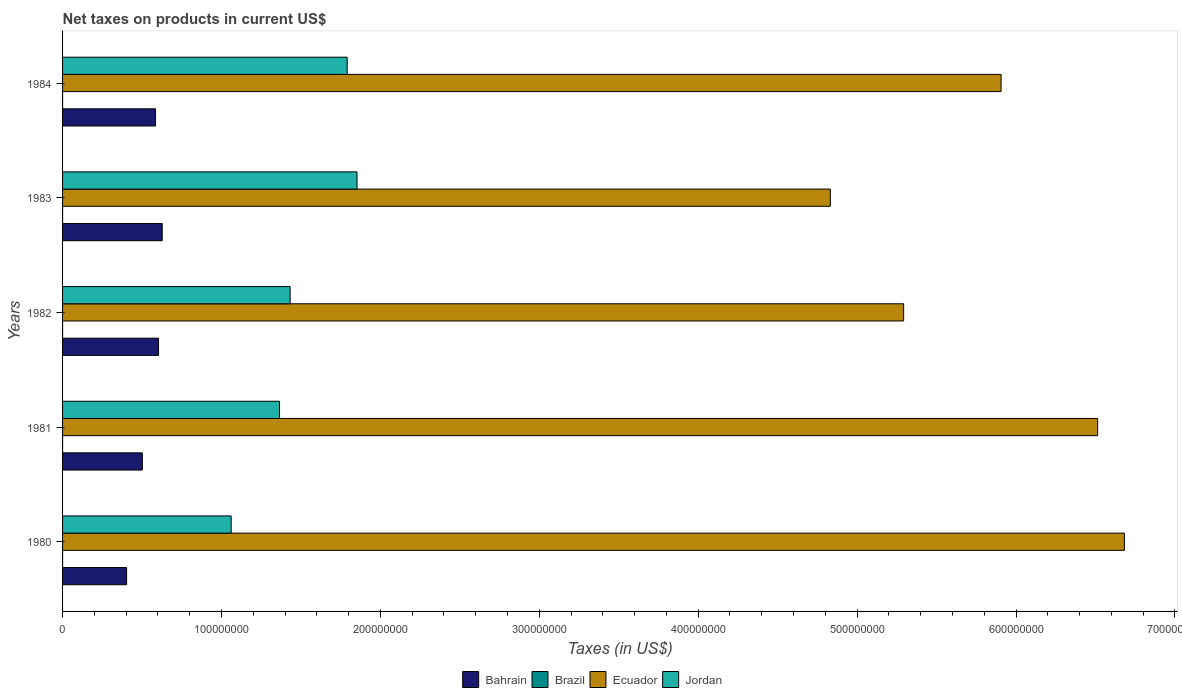How many different coloured bars are there?
Keep it short and to the point. 4. How many bars are there on the 3rd tick from the top?
Offer a very short reply. 4. How many bars are there on the 3rd tick from the bottom?
Ensure brevity in your answer.  4. What is the label of the 2nd group of bars from the top?
Make the answer very short. 1983. In how many cases, is the number of bars for a given year not equal to the number of legend labels?
Offer a very short reply. 0. What is the net taxes on products in Jordan in 1984?
Offer a very short reply. 1.79e+08. Across all years, what is the maximum net taxes on products in Brazil?
Offer a terse response. 12.4. Across all years, what is the minimum net taxes on products in Brazil?
Your answer should be compact. 0.43. What is the total net taxes on products in Ecuador in the graph?
Offer a terse response. 2.92e+09. What is the difference between the net taxes on products in Bahrain in 1981 and that in 1984?
Ensure brevity in your answer.  -8.30e+06. What is the difference between the net taxes on products in Brazil in 1980 and the net taxes on products in Ecuador in 1982?
Your response must be concise. -5.29e+08. What is the average net taxes on products in Bahrain per year?
Ensure brevity in your answer.  5.44e+07. In the year 1983, what is the difference between the net taxes on products in Brazil and net taxes on products in Bahrain?
Provide a succinct answer. -6.27e+07. In how many years, is the net taxes on products in Bahrain greater than 400000000 US$?
Your answer should be compact. 0. What is the ratio of the net taxes on products in Ecuador in 1982 to that in 1983?
Ensure brevity in your answer.  1.1. Is the net taxes on products in Ecuador in 1980 less than that in 1981?
Ensure brevity in your answer.  No. What is the difference between the highest and the second highest net taxes on products in Bahrain?
Make the answer very short. 2.30e+06. What is the difference between the highest and the lowest net taxes on products in Bahrain?
Keep it short and to the point. 2.24e+07. In how many years, is the net taxes on products in Ecuador greater than the average net taxes on products in Ecuador taken over all years?
Your answer should be very brief. 3. Is it the case that in every year, the sum of the net taxes on products in Bahrain and net taxes on products in Brazil is greater than the sum of net taxes on products in Jordan and net taxes on products in Ecuador?
Offer a terse response. No. What does the 3rd bar from the bottom in 1984 represents?
Keep it short and to the point. Ecuador. How many bars are there?
Provide a succinct answer. 20. Are all the bars in the graph horizontal?
Offer a very short reply. Yes. Does the graph contain grids?
Your answer should be very brief. No. What is the title of the graph?
Your answer should be very brief. Net taxes on products in current US$. Does "Middle income" appear as one of the legend labels in the graph?
Keep it short and to the point. No. What is the label or title of the X-axis?
Your answer should be very brief. Taxes (in US$). What is the label or title of the Y-axis?
Keep it short and to the point. Years. What is the Taxes (in US$) in Bahrain in 1980?
Your answer should be very brief. 4.03e+07. What is the Taxes (in US$) in Brazil in 1980?
Give a very brief answer. 0.43. What is the Taxes (in US$) of Ecuador in 1980?
Offer a terse response. 6.68e+08. What is the Taxes (in US$) of Jordan in 1980?
Your answer should be very brief. 1.06e+08. What is the Taxes (in US$) of Bahrain in 1981?
Give a very brief answer. 5.02e+07. What is the Taxes (in US$) of Brazil in 1981?
Offer a terse response. 0.91. What is the Taxes (in US$) of Ecuador in 1981?
Keep it short and to the point. 6.51e+08. What is the Taxes (in US$) in Jordan in 1981?
Provide a succinct answer. 1.36e+08. What is the Taxes (in US$) of Bahrain in 1982?
Offer a terse response. 6.04e+07. What is the Taxes (in US$) in Brazil in 1982?
Your response must be concise. 1.85. What is the Taxes (in US$) in Ecuador in 1982?
Ensure brevity in your answer.  5.29e+08. What is the Taxes (in US$) of Jordan in 1982?
Offer a terse response. 1.43e+08. What is the Taxes (in US$) of Bahrain in 1983?
Your answer should be compact. 6.27e+07. What is the Taxes (in US$) of Brazil in 1983?
Offer a very short reply. 4.33. What is the Taxes (in US$) in Ecuador in 1983?
Make the answer very short. 4.83e+08. What is the Taxes (in US$) of Jordan in 1983?
Your answer should be very brief. 1.85e+08. What is the Taxes (in US$) in Bahrain in 1984?
Give a very brief answer. 5.85e+07. What is the Taxes (in US$) of Brazil in 1984?
Make the answer very short. 12.4. What is the Taxes (in US$) in Ecuador in 1984?
Provide a short and direct response. 5.91e+08. What is the Taxes (in US$) in Jordan in 1984?
Give a very brief answer. 1.79e+08. Across all years, what is the maximum Taxes (in US$) of Bahrain?
Make the answer very short. 6.27e+07. Across all years, what is the maximum Taxes (in US$) of Brazil?
Offer a very short reply. 12.4. Across all years, what is the maximum Taxes (in US$) in Ecuador?
Offer a terse response. 6.68e+08. Across all years, what is the maximum Taxes (in US$) in Jordan?
Your response must be concise. 1.85e+08. Across all years, what is the minimum Taxes (in US$) of Bahrain?
Ensure brevity in your answer.  4.03e+07. Across all years, what is the minimum Taxes (in US$) in Brazil?
Keep it short and to the point. 0.43. Across all years, what is the minimum Taxes (in US$) of Ecuador?
Give a very brief answer. 4.83e+08. Across all years, what is the minimum Taxes (in US$) in Jordan?
Your answer should be compact. 1.06e+08. What is the total Taxes (in US$) of Bahrain in the graph?
Give a very brief answer. 2.72e+08. What is the total Taxes (in US$) in Brazil in the graph?
Provide a short and direct response. 19.94. What is the total Taxes (in US$) in Ecuador in the graph?
Offer a terse response. 2.92e+09. What is the total Taxes (in US$) in Jordan in the graph?
Provide a short and direct response. 7.50e+08. What is the difference between the Taxes (in US$) in Bahrain in 1980 and that in 1981?
Ensure brevity in your answer.  -9.90e+06. What is the difference between the Taxes (in US$) in Brazil in 1980 and that in 1981?
Make the answer very short. -0.48. What is the difference between the Taxes (in US$) in Ecuador in 1980 and that in 1981?
Give a very brief answer. 1.68e+07. What is the difference between the Taxes (in US$) of Jordan in 1980 and that in 1981?
Your answer should be compact. -3.04e+07. What is the difference between the Taxes (in US$) of Bahrain in 1980 and that in 1982?
Provide a short and direct response. -2.01e+07. What is the difference between the Taxes (in US$) in Brazil in 1980 and that in 1982?
Provide a succinct answer. -1.42. What is the difference between the Taxes (in US$) of Ecuador in 1980 and that in 1982?
Keep it short and to the point. 1.39e+08. What is the difference between the Taxes (in US$) of Jordan in 1980 and that in 1982?
Provide a short and direct response. -3.71e+07. What is the difference between the Taxes (in US$) of Bahrain in 1980 and that in 1983?
Make the answer very short. -2.24e+07. What is the difference between the Taxes (in US$) in Brazil in 1980 and that in 1983?
Make the answer very short. -3.9. What is the difference between the Taxes (in US$) in Ecuador in 1980 and that in 1983?
Keep it short and to the point. 1.85e+08. What is the difference between the Taxes (in US$) in Jordan in 1980 and that in 1983?
Your answer should be compact. -7.92e+07. What is the difference between the Taxes (in US$) of Bahrain in 1980 and that in 1984?
Give a very brief answer. -1.82e+07. What is the difference between the Taxes (in US$) of Brazil in 1980 and that in 1984?
Offer a very short reply. -11.97. What is the difference between the Taxes (in US$) of Ecuador in 1980 and that in 1984?
Your answer should be compact. 7.76e+07. What is the difference between the Taxes (in US$) in Jordan in 1980 and that in 1984?
Keep it short and to the point. -7.30e+07. What is the difference between the Taxes (in US$) in Bahrain in 1981 and that in 1982?
Provide a succinct answer. -1.02e+07. What is the difference between the Taxes (in US$) in Brazil in 1981 and that in 1982?
Your answer should be compact. -0.94. What is the difference between the Taxes (in US$) in Ecuador in 1981 and that in 1982?
Provide a succinct answer. 1.22e+08. What is the difference between the Taxes (in US$) in Jordan in 1981 and that in 1982?
Your answer should be compact. -6.70e+06. What is the difference between the Taxes (in US$) in Bahrain in 1981 and that in 1983?
Your answer should be compact. -1.25e+07. What is the difference between the Taxes (in US$) in Brazil in 1981 and that in 1983?
Provide a short and direct response. -3.42. What is the difference between the Taxes (in US$) of Ecuador in 1981 and that in 1983?
Provide a succinct answer. 1.68e+08. What is the difference between the Taxes (in US$) of Jordan in 1981 and that in 1983?
Provide a succinct answer. -4.88e+07. What is the difference between the Taxes (in US$) of Bahrain in 1981 and that in 1984?
Keep it short and to the point. -8.30e+06. What is the difference between the Taxes (in US$) of Brazil in 1981 and that in 1984?
Your answer should be very brief. -11.49. What is the difference between the Taxes (in US$) in Ecuador in 1981 and that in 1984?
Make the answer very short. 6.08e+07. What is the difference between the Taxes (in US$) of Jordan in 1981 and that in 1984?
Offer a very short reply. -4.26e+07. What is the difference between the Taxes (in US$) of Bahrain in 1982 and that in 1983?
Offer a terse response. -2.30e+06. What is the difference between the Taxes (in US$) of Brazil in 1982 and that in 1983?
Provide a succinct answer. -2.48. What is the difference between the Taxes (in US$) in Ecuador in 1982 and that in 1983?
Offer a terse response. 4.61e+07. What is the difference between the Taxes (in US$) in Jordan in 1982 and that in 1983?
Give a very brief answer. -4.21e+07. What is the difference between the Taxes (in US$) of Bahrain in 1982 and that in 1984?
Your response must be concise. 1.90e+06. What is the difference between the Taxes (in US$) in Brazil in 1982 and that in 1984?
Offer a very short reply. -10.55. What is the difference between the Taxes (in US$) of Ecuador in 1982 and that in 1984?
Keep it short and to the point. -6.13e+07. What is the difference between the Taxes (in US$) in Jordan in 1982 and that in 1984?
Provide a succinct answer. -3.59e+07. What is the difference between the Taxes (in US$) of Bahrain in 1983 and that in 1984?
Make the answer very short. 4.20e+06. What is the difference between the Taxes (in US$) of Brazil in 1983 and that in 1984?
Your answer should be compact. -8.07. What is the difference between the Taxes (in US$) of Ecuador in 1983 and that in 1984?
Give a very brief answer. -1.07e+08. What is the difference between the Taxes (in US$) in Jordan in 1983 and that in 1984?
Provide a short and direct response. 6.20e+06. What is the difference between the Taxes (in US$) in Bahrain in 1980 and the Taxes (in US$) in Brazil in 1981?
Ensure brevity in your answer.  4.03e+07. What is the difference between the Taxes (in US$) in Bahrain in 1980 and the Taxes (in US$) in Ecuador in 1981?
Offer a terse response. -6.11e+08. What is the difference between the Taxes (in US$) of Bahrain in 1980 and the Taxes (in US$) of Jordan in 1981?
Keep it short and to the point. -9.62e+07. What is the difference between the Taxes (in US$) of Brazil in 1980 and the Taxes (in US$) of Ecuador in 1981?
Provide a succinct answer. -6.51e+08. What is the difference between the Taxes (in US$) of Brazil in 1980 and the Taxes (in US$) of Jordan in 1981?
Your answer should be compact. -1.36e+08. What is the difference between the Taxes (in US$) of Ecuador in 1980 and the Taxes (in US$) of Jordan in 1981?
Provide a succinct answer. 5.32e+08. What is the difference between the Taxes (in US$) in Bahrain in 1980 and the Taxes (in US$) in Brazil in 1982?
Offer a terse response. 4.03e+07. What is the difference between the Taxes (in US$) in Bahrain in 1980 and the Taxes (in US$) in Ecuador in 1982?
Provide a short and direct response. -4.89e+08. What is the difference between the Taxes (in US$) of Bahrain in 1980 and the Taxes (in US$) of Jordan in 1982?
Your answer should be very brief. -1.03e+08. What is the difference between the Taxes (in US$) in Brazil in 1980 and the Taxes (in US$) in Ecuador in 1982?
Make the answer very short. -5.29e+08. What is the difference between the Taxes (in US$) in Brazil in 1980 and the Taxes (in US$) in Jordan in 1982?
Keep it short and to the point. -1.43e+08. What is the difference between the Taxes (in US$) of Ecuador in 1980 and the Taxes (in US$) of Jordan in 1982?
Your answer should be compact. 5.25e+08. What is the difference between the Taxes (in US$) of Bahrain in 1980 and the Taxes (in US$) of Brazil in 1983?
Offer a very short reply. 4.03e+07. What is the difference between the Taxes (in US$) in Bahrain in 1980 and the Taxes (in US$) in Ecuador in 1983?
Ensure brevity in your answer.  -4.43e+08. What is the difference between the Taxes (in US$) of Bahrain in 1980 and the Taxes (in US$) of Jordan in 1983?
Your response must be concise. -1.45e+08. What is the difference between the Taxes (in US$) in Brazil in 1980 and the Taxes (in US$) in Ecuador in 1983?
Ensure brevity in your answer.  -4.83e+08. What is the difference between the Taxes (in US$) of Brazil in 1980 and the Taxes (in US$) of Jordan in 1983?
Offer a very short reply. -1.85e+08. What is the difference between the Taxes (in US$) of Ecuador in 1980 and the Taxes (in US$) of Jordan in 1983?
Your answer should be very brief. 4.83e+08. What is the difference between the Taxes (in US$) of Bahrain in 1980 and the Taxes (in US$) of Brazil in 1984?
Ensure brevity in your answer.  4.03e+07. What is the difference between the Taxes (in US$) of Bahrain in 1980 and the Taxes (in US$) of Ecuador in 1984?
Give a very brief answer. -5.50e+08. What is the difference between the Taxes (in US$) of Bahrain in 1980 and the Taxes (in US$) of Jordan in 1984?
Your response must be concise. -1.39e+08. What is the difference between the Taxes (in US$) in Brazil in 1980 and the Taxes (in US$) in Ecuador in 1984?
Offer a very short reply. -5.91e+08. What is the difference between the Taxes (in US$) of Brazil in 1980 and the Taxes (in US$) of Jordan in 1984?
Give a very brief answer. -1.79e+08. What is the difference between the Taxes (in US$) in Ecuador in 1980 and the Taxes (in US$) in Jordan in 1984?
Your answer should be very brief. 4.89e+08. What is the difference between the Taxes (in US$) of Bahrain in 1981 and the Taxes (in US$) of Brazil in 1982?
Keep it short and to the point. 5.02e+07. What is the difference between the Taxes (in US$) of Bahrain in 1981 and the Taxes (in US$) of Ecuador in 1982?
Provide a short and direct response. -4.79e+08. What is the difference between the Taxes (in US$) of Bahrain in 1981 and the Taxes (in US$) of Jordan in 1982?
Provide a short and direct response. -9.30e+07. What is the difference between the Taxes (in US$) of Brazil in 1981 and the Taxes (in US$) of Ecuador in 1982?
Offer a terse response. -5.29e+08. What is the difference between the Taxes (in US$) in Brazil in 1981 and the Taxes (in US$) in Jordan in 1982?
Provide a short and direct response. -1.43e+08. What is the difference between the Taxes (in US$) in Ecuador in 1981 and the Taxes (in US$) in Jordan in 1982?
Make the answer very short. 5.08e+08. What is the difference between the Taxes (in US$) in Bahrain in 1981 and the Taxes (in US$) in Brazil in 1983?
Your answer should be very brief. 5.02e+07. What is the difference between the Taxes (in US$) of Bahrain in 1981 and the Taxes (in US$) of Ecuador in 1983?
Give a very brief answer. -4.33e+08. What is the difference between the Taxes (in US$) in Bahrain in 1981 and the Taxes (in US$) in Jordan in 1983?
Offer a very short reply. -1.35e+08. What is the difference between the Taxes (in US$) in Brazil in 1981 and the Taxes (in US$) in Ecuador in 1983?
Make the answer very short. -4.83e+08. What is the difference between the Taxes (in US$) of Brazil in 1981 and the Taxes (in US$) of Jordan in 1983?
Give a very brief answer. -1.85e+08. What is the difference between the Taxes (in US$) in Ecuador in 1981 and the Taxes (in US$) in Jordan in 1983?
Make the answer very short. 4.66e+08. What is the difference between the Taxes (in US$) of Bahrain in 1981 and the Taxes (in US$) of Brazil in 1984?
Ensure brevity in your answer.  5.02e+07. What is the difference between the Taxes (in US$) of Bahrain in 1981 and the Taxes (in US$) of Ecuador in 1984?
Your response must be concise. -5.40e+08. What is the difference between the Taxes (in US$) of Bahrain in 1981 and the Taxes (in US$) of Jordan in 1984?
Ensure brevity in your answer.  -1.29e+08. What is the difference between the Taxes (in US$) in Brazil in 1981 and the Taxes (in US$) in Ecuador in 1984?
Offer a very short reply. -5.91e+08. What is the difference between the Taxes (in US$) of Brazil in 1981 and the Taxes (in US$) of Jordan in 1984?
Offer a terse response. -1.79e+08. What is the difference between the Taxes (in US$) of Ecuador in 1981 and the Taxes (in US$) of Jordan in 1984?
Your response must be concise. 4.72e+08. What is the difference between the Taxes (in US$) of Bahrain in 1982 and the Taxes (in US$) of Brazil in 1983?
Provide a succinct answer. 6.04e+07. What is the difference between the Taxes (in US$) of Bahrain in 1982 and the Taxes (in US$) of Ecuador in 1983?
Your answer should be very brief. -4.23e+08. What is the difference between the Taxes (in US$) of Bahrain in 1982 and the Taxes (in US$) of Jordan in 1983?
Keep it short and to the point. -1.25e+08. What is the difference between the Taxes (in US$) in Brazil in 1982 and the Taxes (in US$) in Ecuador in 1983?
Provide a short and direct response. -4.83e+08. What is the difference between the Taxes (in US$) in Brazil in 1982 and the Taxes (in US$) in Jordan in 1983?
Your answer should be very brief. -1.85e+08. What is the difference between the Taxes (in US$) of Ecuador in 1982 and the Taxes (in US$) of Jordan in 1983?
Offer a very short reply. 3.44e+08. What is the difference between the Taxes (in US$) of Bahrain in 1982 and the Taxes (in US$) of Brazil in 1984?
Give a very brief answer. 6.04e+07. What is the difference between the Taxes (in US$) in Bahrain in 1982 and the Taxes (in US$) in Ecuador in 1984?
Offer a terse response. -5.30e+08. What is the difference between the Taxes (in US$) of Bahrain in 1982 and the Taxes (in US$) of Jordan in 1984?
Your answer should be very brief. -1.19e+08. What is the difference between the Taxes (in US$) in Brazil in 1982 and the Taxes (in US$) in Ecuador in 1984?
Ensure brevity in your answer.  -5.91e+08. What is the difference between the Taxes (in US$) in Brazil in 1982 and the Taxes (in US$) in Jordan in 1984?
Provide a succinct answer. -1.79e+08. What is the difference between the Taxes (in US$) of Ecuador in 1982 and the Taxes (in US$) of Jordan in 1984?
Give a very brief answer. 3.50e+08. What is the difference between the Taxes (in US$) of Bahrain in 1983 and the Taxes (in US$) of Brazil in 1984?
Offer a terse response. 6.27e+07. What is the difference between the Taxes (in US$) of Bahrain in 1983 and the Taxes (in US$) of Ecuador in 1984?
Keep it short and to the point. -5.28e+08. What is the difference between the Taxes (in US$) in Bahrain in 1983 and the Taxes (in US$) in Jordan in 1984?
Keep it short and to the point. -1.16e+08. What is the difference between the Taxes (in US$) of Brazil in 1983 and the Taxes (in US$) of Ecuador in 1984?
Your answer should be very brief. -5.91e+08. What is the difference between the Taxes (in US$) of Brazil in 1983 and the Taxes (in US$) of Jordan in 1984?
Ensure brevity in your answer.  -1.79e+08. What is the difference between the Taxes (in US$) of Ecuador in 1983 and the Taxes (in US$) of Jordan in 1984?
Ensure brevity in your answer.  3.04e+08. What is the average Taxes (in US$) in Bahrain per year?
Provide a succinct answer. 5.44e+07. What is the average Taxes (in US$) in Brazil per year?
Provide a succinct answer. 3.99. What is the average Taxes (in US$) in Ecuador per year?
Offer a terse response. 5.85e+08. What is the average Taxes (in US$) of Jordan per year?
Provide a short and direct response. 1.50e+08. In the year 1980, what is the difference between the Taxes (in US$) of Bahrain and Taxes (in US$) of Brazil?
Provide a short and direct response. 4.03e+07. In the year 1980, what is the difference between the Taxes (in US$) in Bahrain and Taxes (in US$) in Ecuador?
Ensure brevity in your answer.  -6.28e+08. In the year 1980, what is the difference between the Taxes (in US$) in Bahrain and Taxes (in US$) in Jordan?
Offer a very short reply. -6.58e+07. In the year 1980, what is the difference between the Taxes (in US$) of Brazil and Taxes (in US$) of Ecuador?
Keep it short and to the point. -6.68e+08. In the year 1980, what is the difference between the Taxes (in US$) of Brazil and Taxes (in US$) of Jordan?
Offer a very short reply. -1.06e+08. In the year 1980, what is the difference between the Taxes (in US$) in Ecuador and Taxes (in US$) in Jordan?
Make the answer very short. 5.62e+08. In the year 1981, what is the difference between the Taxes (in US$) of Bahrain and Taxes (in US$) of Brazil?
Provide a short and direct response. 5.02e+07. In the year 1981, what is the difference between the Taxes (in US$) of Bahrain and Taxes (in US$) of Ecuador?
Give a very brief answer. -6.01e+08. In the year 1981, what is the difference between the Taxes (in US$) of Bahrain and Taxes (in US$) of Jordan?
Make the answer very short. -8.63e+07. In the year 1981, what is the difference between the Taxes (in US$) in Brazil and Taxes (in US$) in Ecuador?
Your answer should be compact. -6.51e+08. In the year 1981, what is the difference between the Taxes (in US$) in Brazil and Taxes (in US$) in Jordan?
Offer a very short reply. -1.36e+08. In the year 1981, what is the difference between the Taxes (in US$) of Ecuador and Taxes (in US$) of Jordan?
Your answer should be compact. 5.15e+08. In the year 1982, what is the difference between the Taxes (in US$) of Bahrain and Taxes (in US$) of Brazil?
Your answer should be compact. 6.04e+07. In the year 1982, what is the difference between the Taxes (in US$) in Bahrain and Taxes (in US$) in Ecuador?
Ensure brevity in your answer.  -4.69e+08. In the year 1982, what is the difference between the Taxes (in US$) of Bahrain and Taxes (in US$) of Jordan?
Make the answer very short. -8.28e+07. In the year 1982, what is the difference between the Taxes (in US$) in Brazil and Taxes (in US$) in Ecuador?
Offer a terse response. -5.29e+08. In the year 1982, what is the difference between the Taxes (in US$) in Brazil and Taxes (in US$) in Jordan?
Offer a terse response. -1.43e+08. In the year 1982, what is the difference between the Taxes (in US$) in Ecuador and Taxes (in US$) in Jordan?
Your answer should be very brief. 3.86e+08. In the year 1983, what is the difference between the Taxes (in US$) of Bahrain and Taxes (in US$) of Brazil?
Offer a very short reply. 6.27e+07. In the year 1983, what is the difference between the Taxes (in US$) of Bahrain and Taxes (in US$) of Ecuador?
Provide a succinct answer. -4.20e+08. In the year 1983, what is the difference between the Taxes (in US$) of Bahrain and Taxes (in US$) of Jordan?
Make the answer very short. -1.23e+08. In the year 1983, what is the difference between the Taxes (in US$) in Brazil and Taxes (in US$) in Ecuador?
Offer a very short reply. -4.83e+08. In the year 1983, what is the difference between the Taxes (in US$) of Brazil and Taxes (in US$) of Jordan?
Give a very brief answer. -1.85e+08. In the year 1983, what is the difference between the Taxes (in US$) in Ecuador and Taxes (in US$) in Jordan?
Offer a very short reply. 2.98e+08. In the year 1984, what is the difference between the Taxes (in US$) in Bahrain and Taxes (in US$) in Brazil?
Ensure brevity in your answer.  5.85e+07. In the year 1984, what is the difference between the Taxes (in US$) in Bahrain and Taxes (in US$) in Ecuador?
Ensure brevity in your answer.  -5.32e+08. In the year 1984, what is the difference between the Taxes (in US$) in Bahrain and Taxes (in US$) in Jordan?
Make the answer very short. -1.21e+08. In the year 1984, what is the difference between the Taxes (in US$) in Brazil and Taxes (in US$) in Ecuador?
Your response must be concise. -5.91e+08. In the year 1984, what is the difference between the Taxes (in US$) of Brazil and Taxes (in US$) of Jordan?
Give a very brief answer. -1.79e+08. In the year 1984, what is the difference between the Taxes (in US$) in Ecuador and Taxes (in US$) in Jordan?
Ensure brevity in your answer.  4.12e+08. What is the ratio of the Taxes (in US$) in Bahrain in 1980 to that in 1981?
Give a very brief answer. 0.8. What is the ratio of the Taxes (in US$) of Brazil in 1980 to that in 1981?
Make the answer very short. 0.48. What is the ratio of the Taxes (in US$) of Ecuador in 1980 to that in 1981?
Keep it short and to the point. 1.03. What is the ratio of the Taxes (in US$) of Jordan in 1980 to that in 1981?
Your response must be concise. 0.78. What is the ratio of the Taxes (in US$) in Bahrain in 1980 to that in 1982?
Keep it short and to the point. 0.67. What is the ratio of the Taxes (in US$) of Brazil in 1980 to that in 1982?
Give a very brief answer. 0.23. What is the ratio of the Taxes (in US$) in Ecuador in 1980 to that in 1982?
Provide a succinct answer. 1.26. What is the ratio of the Taxes (in US$) of Jordan in 1980 to that in 1982?
Your answer should be compact. 0.74. What is the ratio of the Taxes (in US$) of Bahrain in 1980 to that in 1983?
Ensure brevity in your answer.  0.64. What is the ratio of the Taxes (in US$) of Brazil in 1980 to that in 1983?
Your answer should be very brief. 0.1. What is the ratio of the Taxes (in US$) in Ecuador in 1980 to that in 1983?
Offer a very short reply. 1.38. What is the ratio of the Taxes (in US$) of Jordan in 1980 to that in 1983?
Offer a very short reply. 0.57. What is the ratio of the Taxes (in US$) in Bahrain in 1980 to that in 1984?
Give a very brief answer. 0.69. What is the ratio of the Taxes (in US$) in Brazil in 1980 to that in 1984?
Provide a short and direct response. 0.04. What is the ratio of the Taxes (in US$) in Ecuador in 1980 to that in 1984?
Your response must be concise. 1.13. What is the ratio of the Taxes (in US$) of Jordan in 1980 to that in 1984?
Your answer should be compact. 0.59. What is the ratio of the Taxes (in US$) in Bahrain in 1981 to that in 1982?
Your answer should be compact. 0.83. What is the ratio of the Taxes (in US$) of Brazil in 1981 to that in 1982?
Your answer should be very brief. 0.49. What is the ratio of the Taxes (in US$) in Ecuador in 1981 to that in 1982?
Offer a very short reply. 1.23. What is the ratio of the Taxes (in US$) in Jordan in 1981 to that in 1982?
Your answer should be compact. 0.95. What is the ratio of the Taxes (in US$) of Bahrain in 1981 to that in 1983?
Give a very brief answer. 0.8. What is the ratio of the Taxes (in US$) of Brazil in 1981 to that in 1983?
Keep it short and to the point. 0.21. What is the ratio of the Taxes (in US$) of Ecuador in 1981 to that in 1983?
Offer a terse response. 1.35. What is the ratio of the Taxes (in US$) in Jordan in 1981 to that in 1983?
Your answer should be compact. 0.74. What is the ratio of the Taxes (in US$) in Bahrain in 1981 to that in 1984?
Offer a very short reply. 0.86. What is the ratio of the Taxes (in US$) in Brazil in 1981 to that in 1984?
Provide a short and direct response. 0.07. What is the ratio of the Taxes (in US$) of Ecuador in 1981 to that in 1984?
Make the answer very short. 1.1. What is the ratio of the Taxes (in US$) in Jordan in 1981 to that in 1984?
Keep it short and to the point. 0.76. What is the ratio of the Taxes (in US$) of Bahrain in 1982 to that in 1983?
Ensure brevity in your answer.  0.96. What is the ratio of the Taxes (in US$) in Brazil in 1982 to that in 1983?
Make the answer very short. 0.43. What is the ratio of the Taxes (in US$) in Ecuador in 1982 to that in 1983?
Offer a very short reply. 1.1. What is the ratio of the Taxes (in US$) in Jordan in 1982 to that in 1983?
Give a very brief answer. 0.77. What is the ratio of the Taxes (in US$) in Bahrain in 1982 to that in 1984?
Provide a short and direct response. 1.03. What is the ratio of the Taxes (in US$) in Brazil in 1982 to that in 1984?
Keep it short and to the point. 0.15. What is the ratio of the Taxes (in US$) of Ecuador in 1982 to that in 1984?
Offer a very short reply. 0.9. What is the ratio of the Taxes (in US$) in Jordan in 1982 to that in 1984?
Your answer should be compact. 0.8. What is the ratio of the Taxes (in US$) of Bahrain in 1983 to that in 1984?
Offer a very short reply. 1.07. What is the ratio of the Taxes (in US$) in Brazil in 1983 to that in 1984?
Offer a terse response. 0.35. What is the ratio of the Taxes (in US$) in Ecuador in 1983 to that in 1984?
Your answer should be compact. 0.82. What is the ratio of the Taxes (in US$) of Jordan in 1983 to that in 1984?
Your answer should be very brief. 1.03. What is the difference between the highest and the second highest Taxes (in US$) of Bahrain?
Provide a succinct answer. 2.30e+06. What is the difference between the highest and the second highest Taxes (in US$) of Brazil?
Offer a terse response. 8.07. What is the difference between the highest and the second highest Taxes (in US$) in Ecuador?
Your answer should be very brief. 1.68e+07. What is the difference between the highest and the second highest Taxes (in US$) of Jordan?
Your response must be concise. 6.20e+06. What is the difference between the highest and the lowest Taxes (in US$) in Bahrain?
Your response must be concise. 2.24e+07. What is the difference between the highest and the lowest Taxes (in US$) in Brazil?
Make the answer very short. 11.97. What is the difference between the highest and the lowest Taxes (in US$) of Ecuador?
Ensure brevity in your answer.  1.85e+08. What is the difference between the highest and the lowest Taxes (in US$) in Jordan?
Your response must be concise. 7.92e+07. 